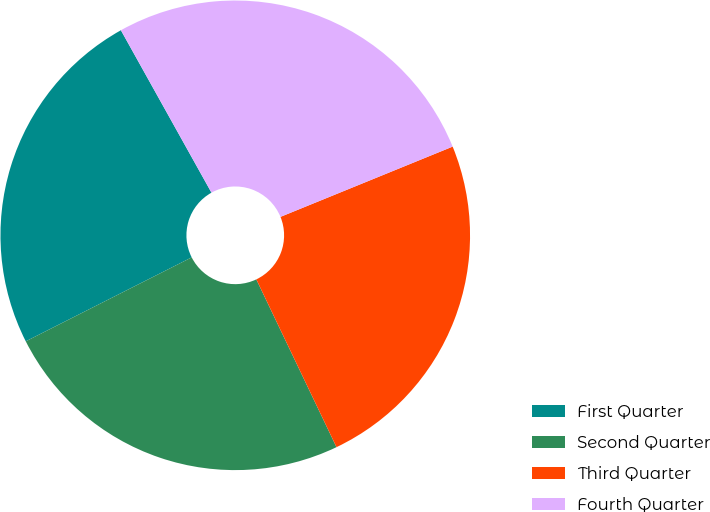Convert chart. <chart><loc_0><loc_0><loc_500><loc_500><pie_chart><fcel>First Quarter<fcel>Second Quarter<fcel>Third Quarter<fcel>Fourth Quarter<nl><fcel>24.36%<fcel>24.64%<fcel>24.07%<fcel>26.93%<nl></chart> 